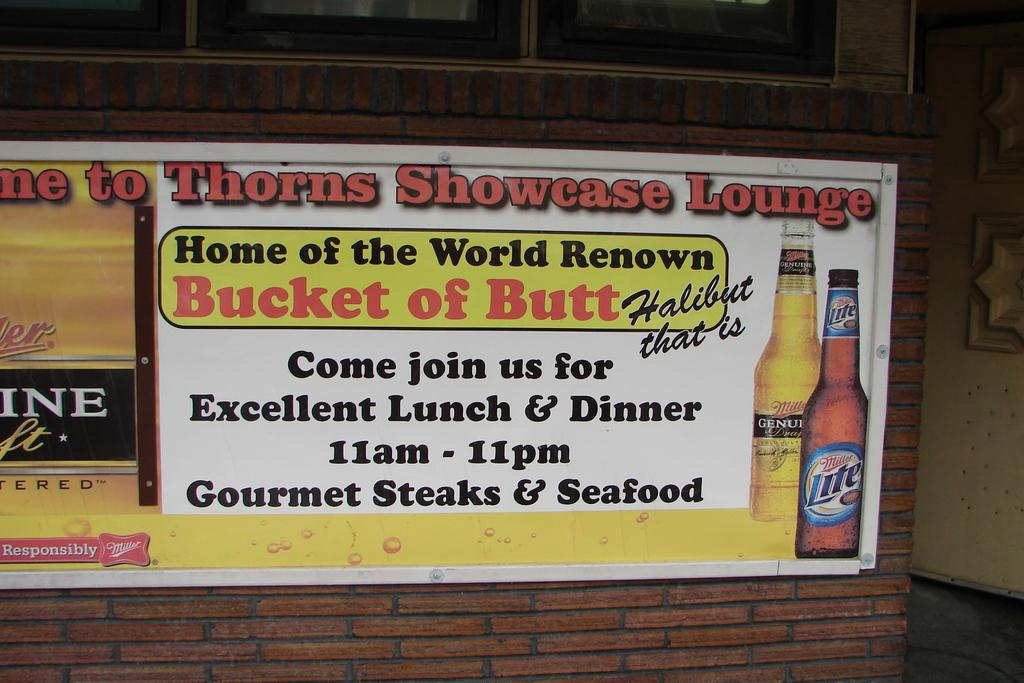Provide a one-sentence caption for the provided image. An advertisement for Thorns Showcase Lounge to join them for lunch and dinner. 